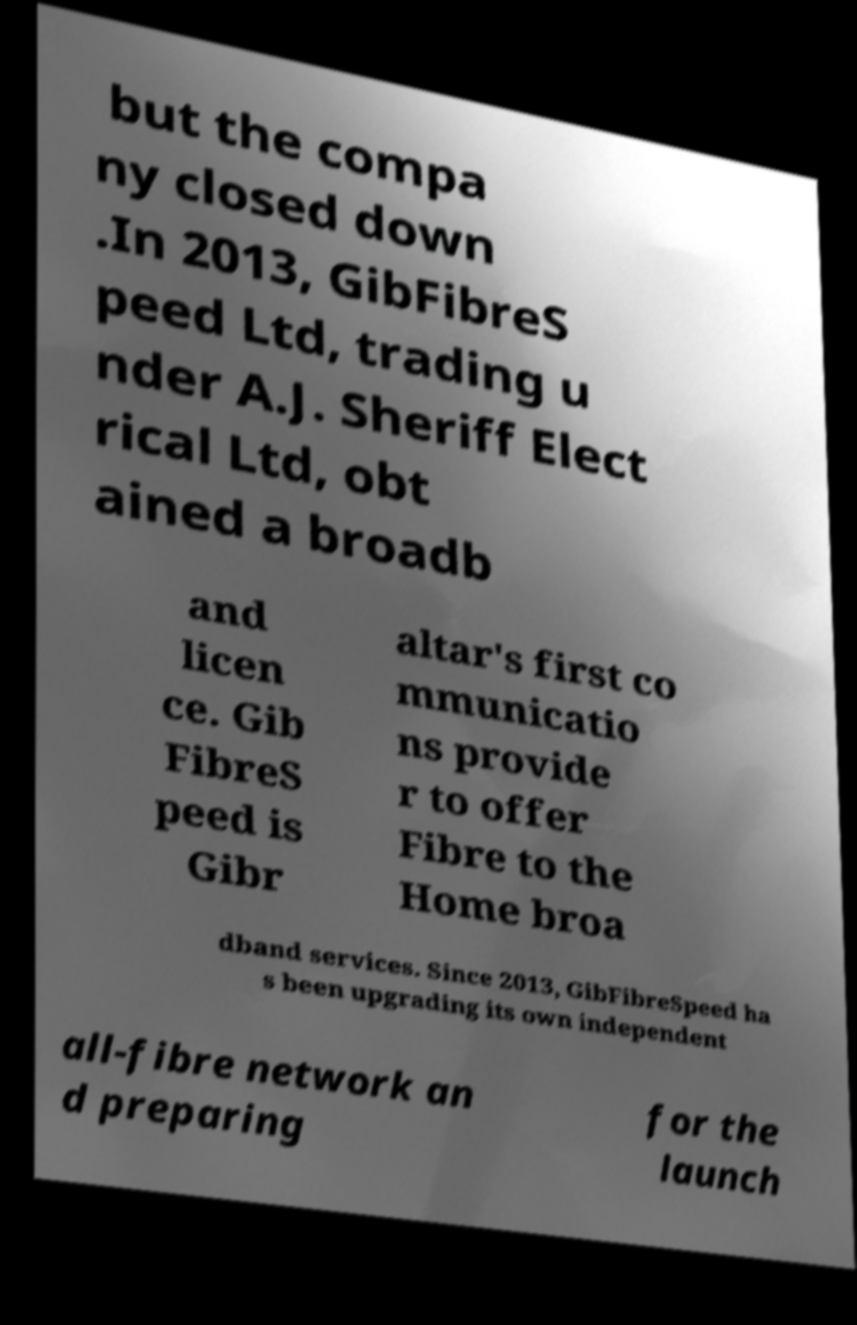I need the written content from this picture converted into text. Can you do that? but the compa ny closed down .In 2013, GibFibreS peed Ltd, trading u nder A.J. Sheriff Elect rical Ltd, obt ained a broadb and licen ce. Gib FibreS peed is Gibr altar's first co mmunicatio ns provide r to offer Fibre to the Home broa dband services. Since 2013, GibFibreSpeed ha s been upgrading its own independent all-fibre network an d preparing for the launch 